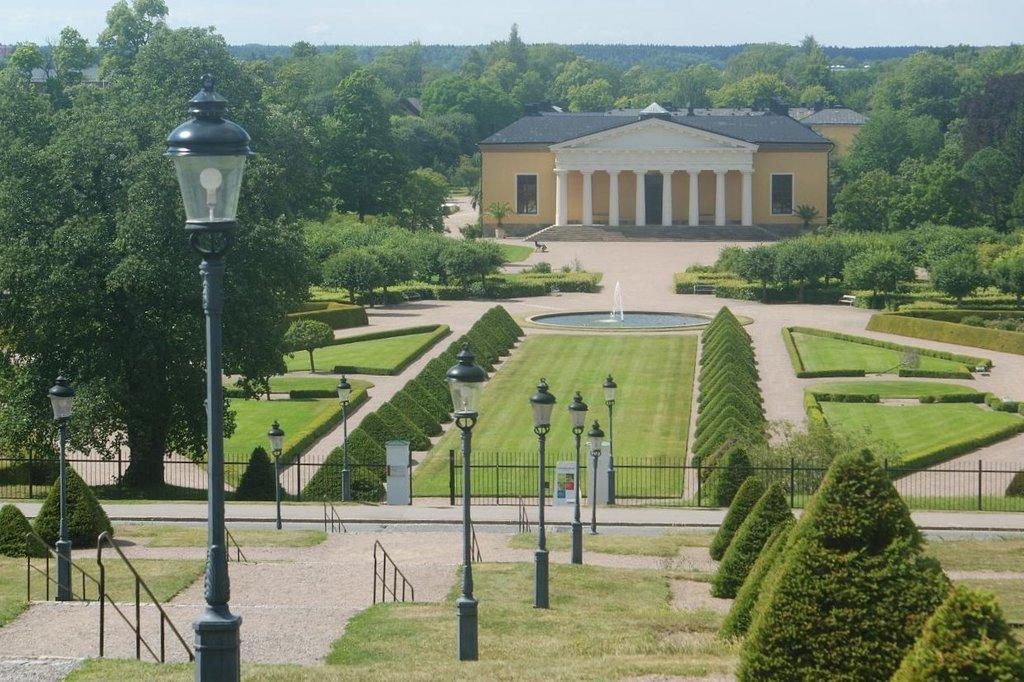Describe this image in one or two sentences. At the bottom, we see the grass, trees, stairs, stair railing and the light poles. In the middle, we see the road, railing, grass, trees and a water fountain. There are trees and a building in the background. At the top, we see the sky. 